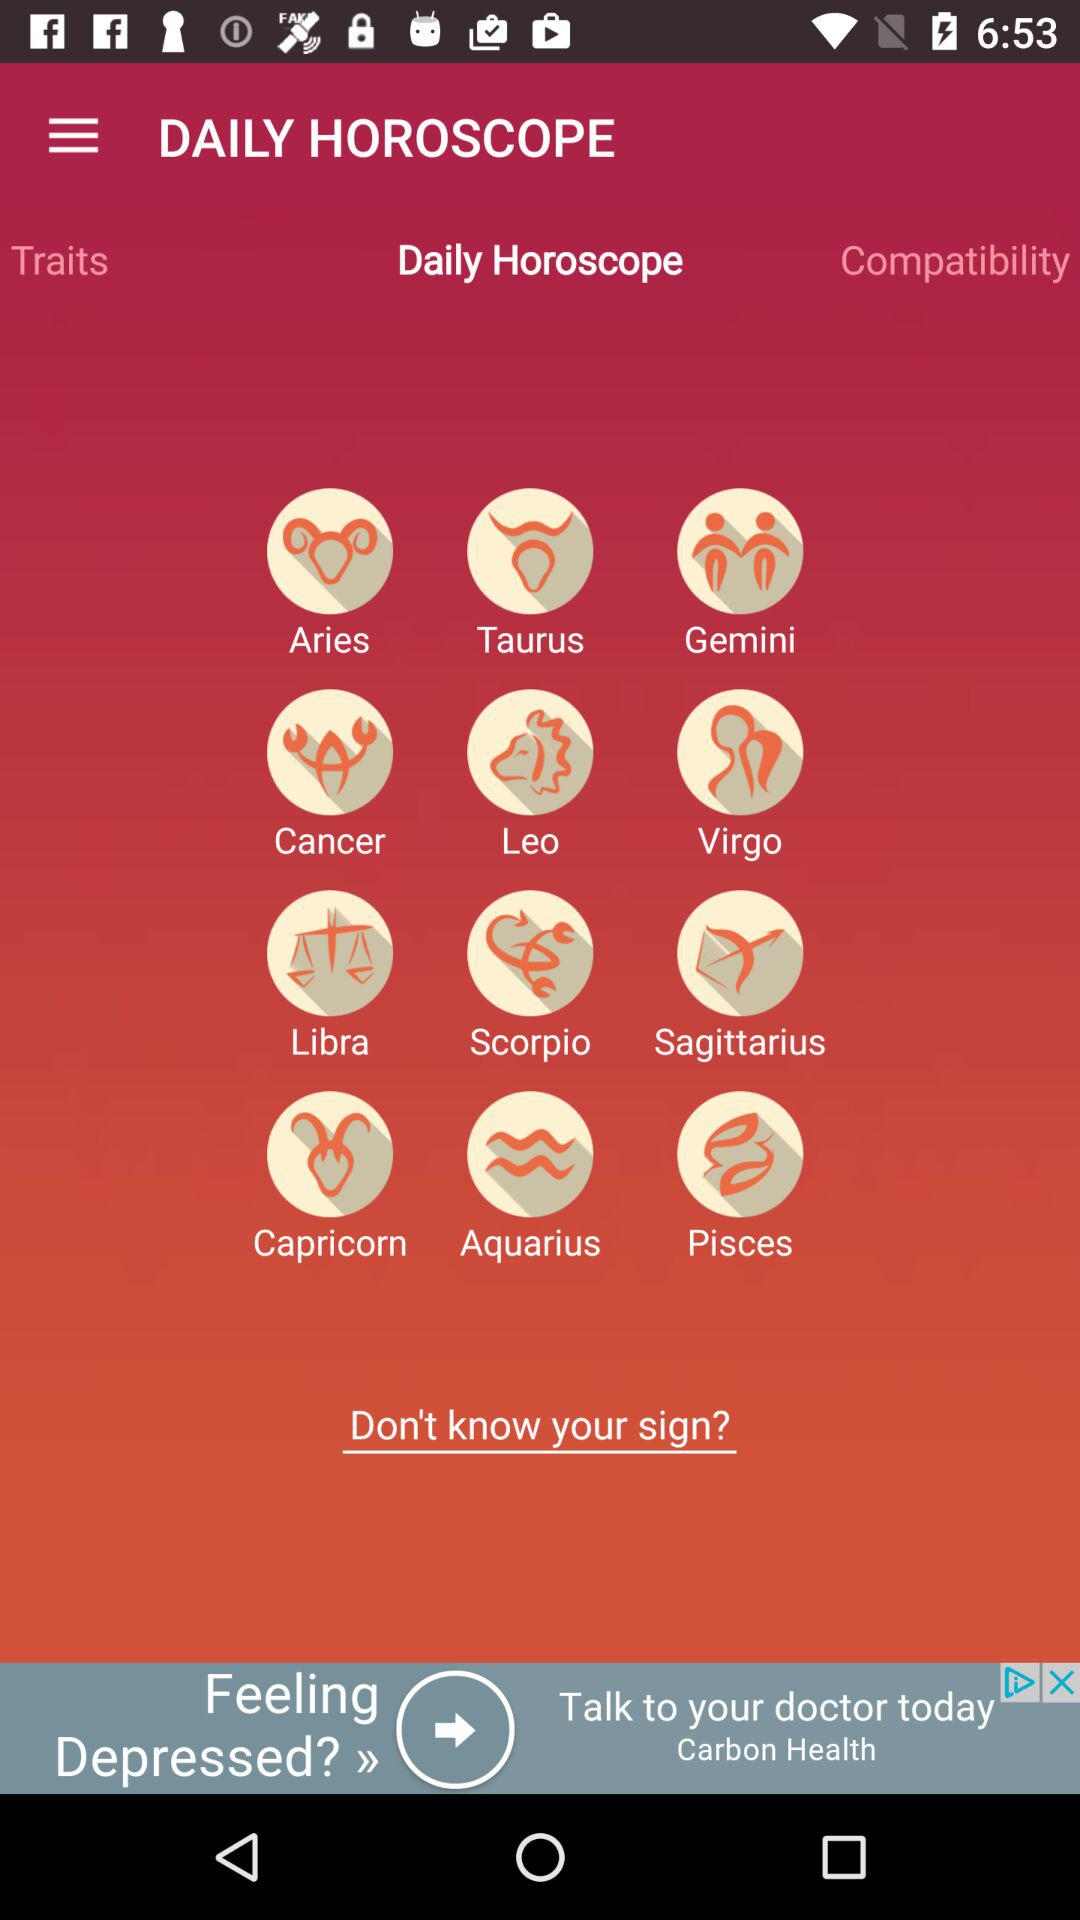What is the name of the application? The name of the application is "DAILY HOROSCOPE". 